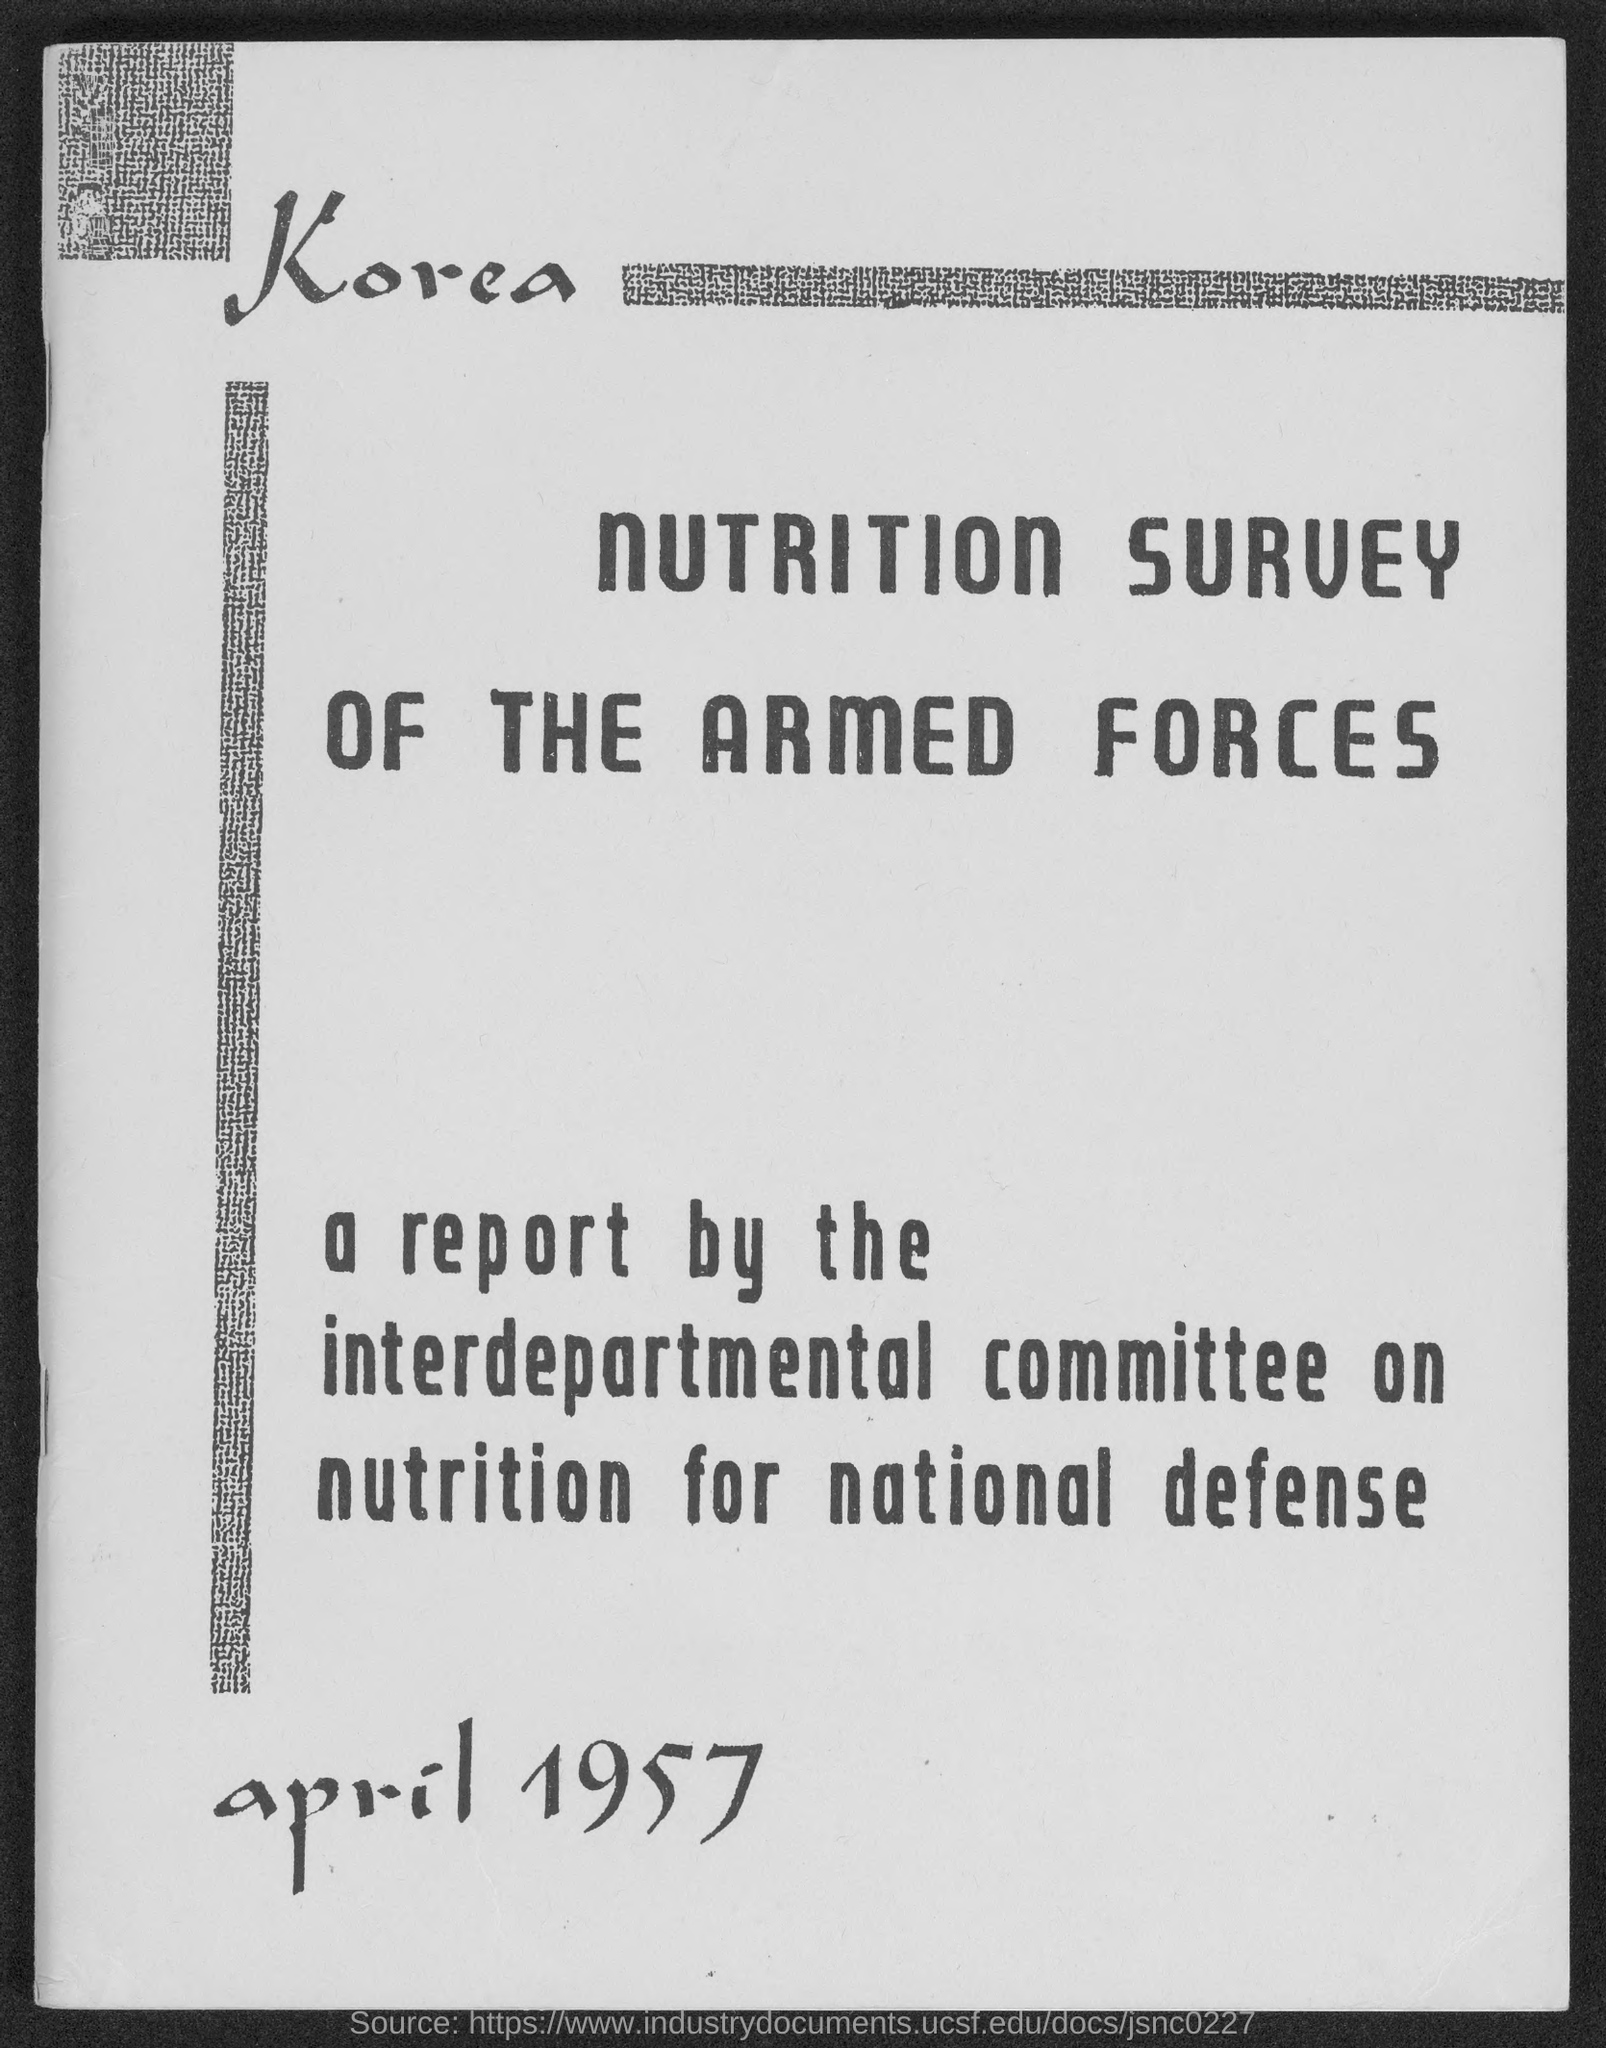Give some essential details in this illustration. The month and year at the bottom of the page are April 1957. 